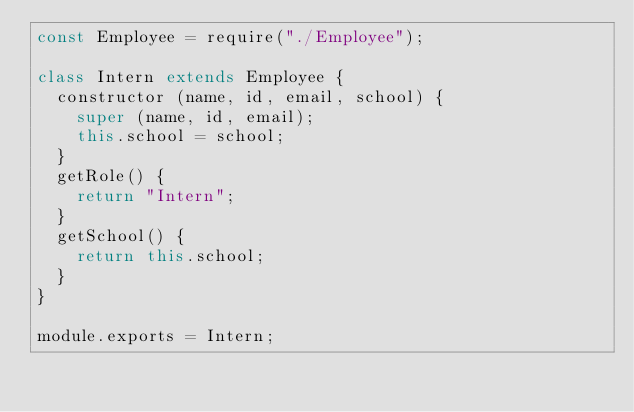<code> <loc_0><loc_0><loc_500><loc_500><_JavaScript_>const Employee = require("./Employee");

class Intern extends Employee {
  constructor (name, id, email, school) {
    super (name, id, email);
    this.school = school;
  }
  getRole() {
    return "Intern";
  }
  getSchool() {
    return this.school;
  }
}

module.exports = Intern;</code> 